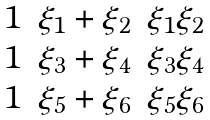<formula> <loc_0><loc_0><loc_500><loc_500>\begin{matrix} 1 & \xi _ { 1 } + \xi _ { 2 } & \xi _ { 1 } \xi _ { 2 } \\ 1 & \xi _ { 3 } + \xi _ { 4 } & \xi _ { 3 } \xi _ { 4 } \\ 1 & \xi _ { 5 } + \xi _ { 6 } & \xi _ { 5 } \xi _ { 6 } \end{matrix}</formula> 